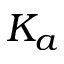<formula> <loc_0><loc_0><loc_500><loc_500>K _ { a }</formula> 